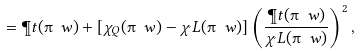Convert formula to latex. <formula><loc_0><loc_0><loc_500><loc_500>= \P t ( \i \ w ) + [ \chi _ { Q } ( \i \ w ) - \chi _ { \L } L ( \i \ w ) ] \left ( \frac { \P t ( \i \ w ) } { \chi _ { \L } L ( \i \ w ) } \right ) ^ { 2 } ,</formula> 